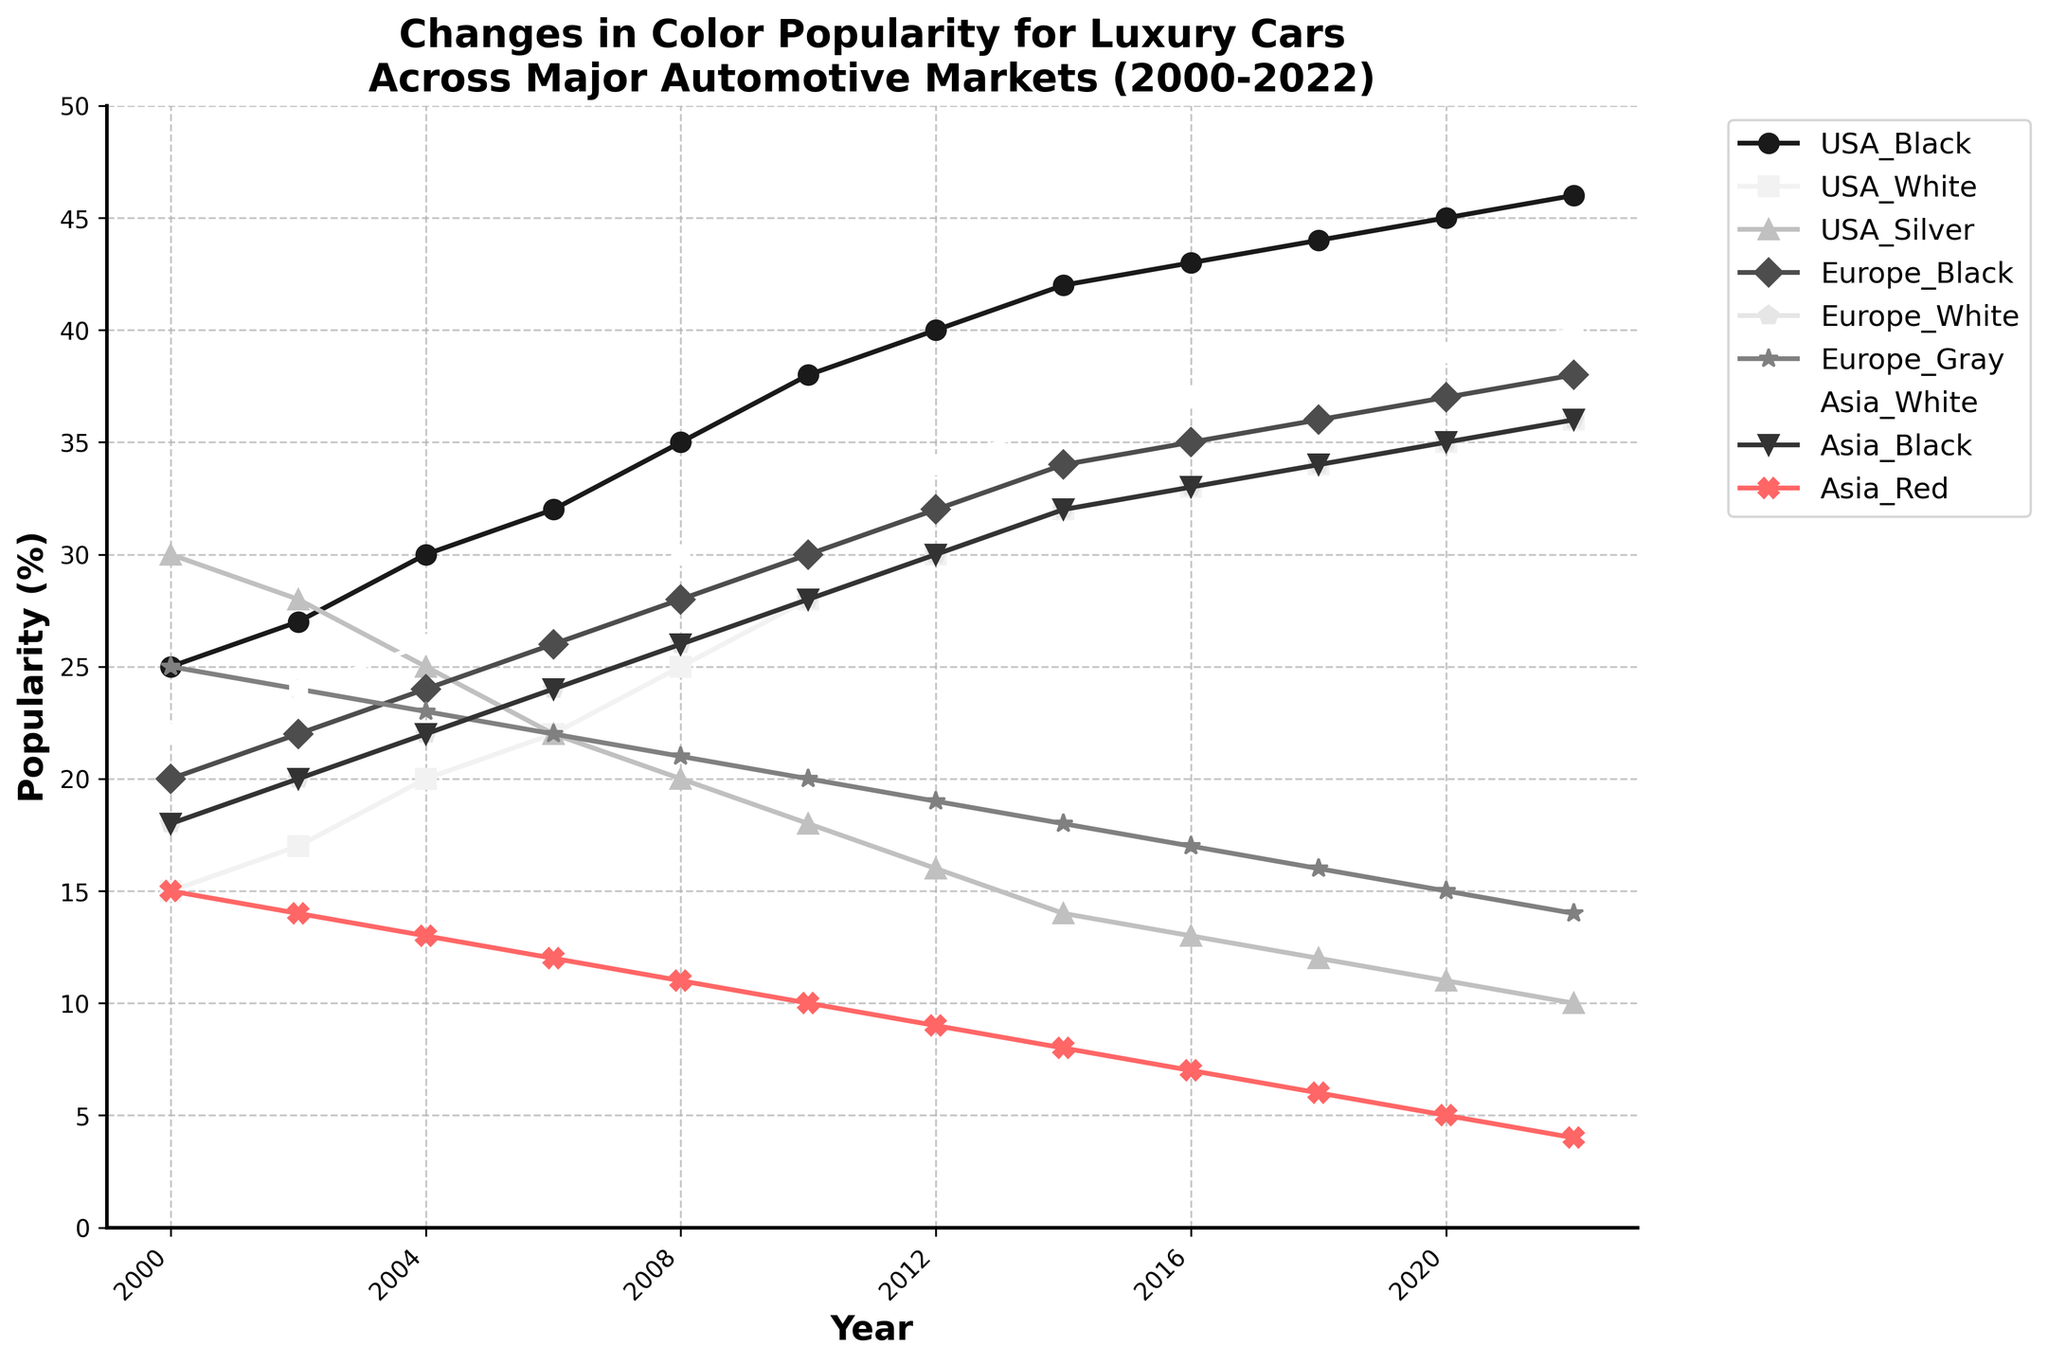Which color was the most popular for luxury cars in the USA in 2000? By looking at the heights of the different lines representing color popularity in the USA for the year 2000, the silver color has the highest value.
Answer: Silver How did the popularity of black cars in Europe change from 2000 to 2022? From 2000 to 2022, the popularity of black cars in Europe increased consistently, starting at 20% in 2000 and reaching 38% in 2022.
Answer: It increased What is the difference in popularity between black and white cars in the USA in 2012? The popularity of black cars in the USA in 2012 is 40%, and white cars are 30%. The difference is 40% - 30% = 10%.
Answer: 10% Which region had the highest popularity for white cars in 2020? By comparing the popularity lines for white cars across USA, Europe, and Asia in 2020, Asia shows the highest value at 39%.
Answer: Asia What is the general trend in the popularity of silver cars in the USA from 2000 to 2022? The popularity of silver cars in the USA saw a steady decline from 2000 (30%) to 2022 (10%).
Answer: Declining What is the average popularity of black cars in the USA from 2000 to 2022? The popularity values for black cars in the USA over the years are: 25, 27, 30, 32, 35, 38, 40, 42, 43, 44, 45, 46. Summing these values gives 447, and the number of years is 12. Thus, the average is 447 / 12 ≈ 37.25.
Answer: 37.25% In 2022, which color was more popular in Europe: gray or white? In 2022, gray cars in Europe had a popularity of 14%, whereas white cars had 36%, as seen from the line chart. Thus, white was more popular.
Answer: White How did the popularity of red cars in Asia change from 2000 to 2022? The popularity of red cars in Asia consistently decreased from 15% in 2000 to 4% in 2022.
Answer: Decreased Which color saw an increase in popularity in all three regions from 2000 to 2022? By examining the line trends, black color saw an increase in popularity uniformly in the USA, Europe, and Asia from 2000 to 2022.
Answer: Black What is the sum of the popularity percentages of black and gray cars in Europe in 2014? In 2014, the popularity of black cars in Europe is 34%, and gray cars are 18%. Summing these gives 34% + 18% = 52%.
Answer: 52% 